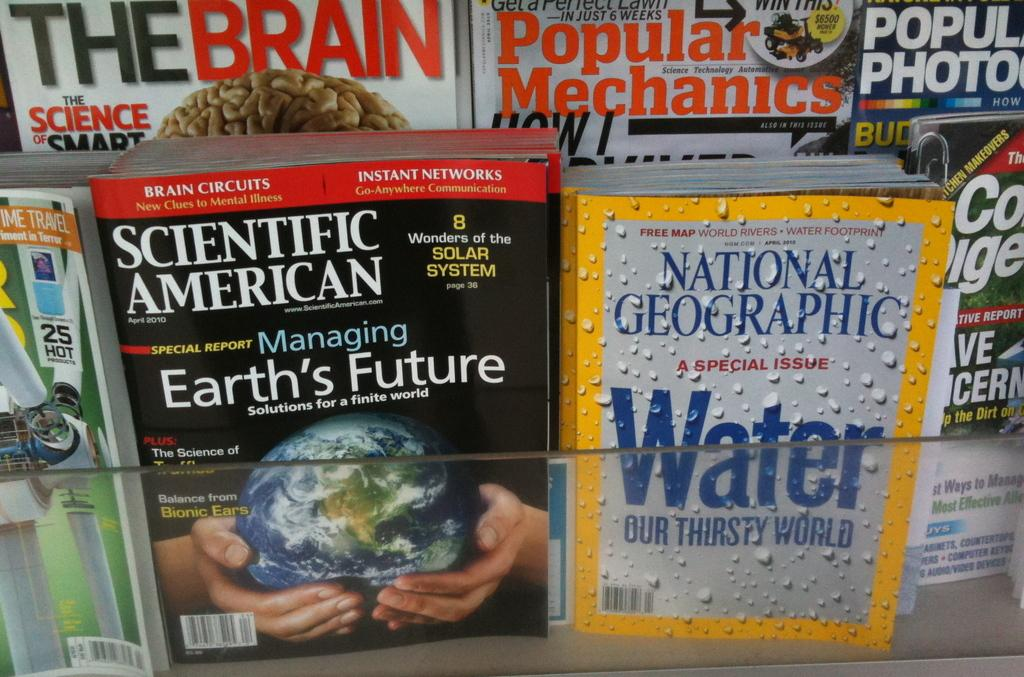What type of reading material is present in the image? There are magazines in the image. What can be seen on the front of the magazines? The magazines have cover pages. What is featured on the cover pages of the magazines? There is text and pictures on the cover pages of the magazines. How does the kite perform magic tricks in the image? There is no kite present in the image, and therefore no such activity can be observed. 